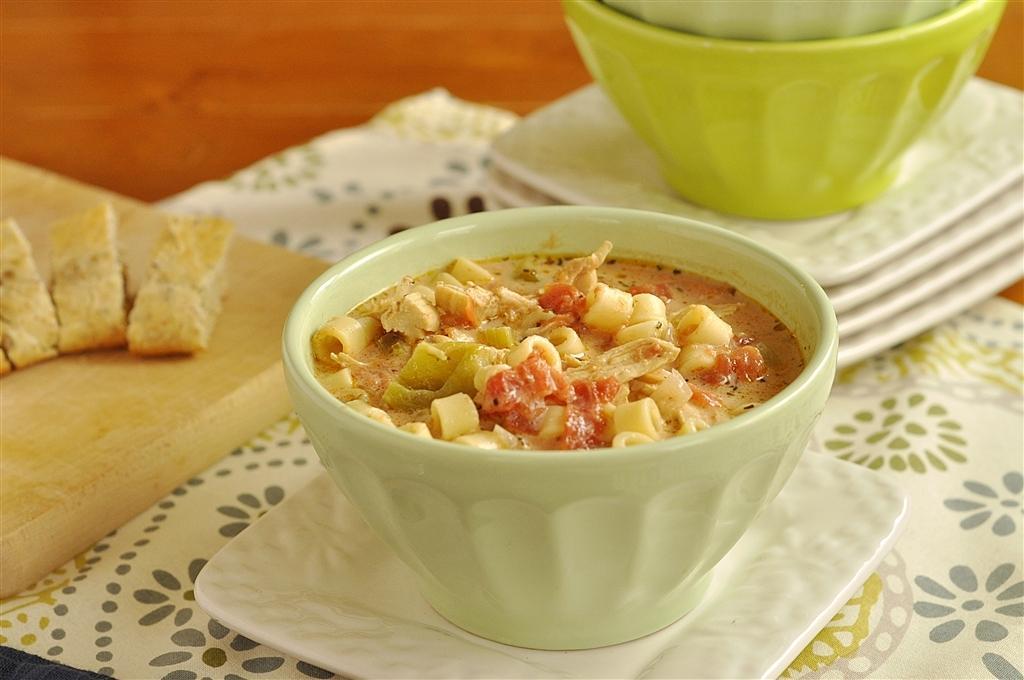Can you describe this image briefly? Here in this picture we can see a table, on which in the front we can see a bowl of food present on a plate over there and beside that we can see other bowls and plate present and on the left side we can see some bread pieces present on a board over there. 